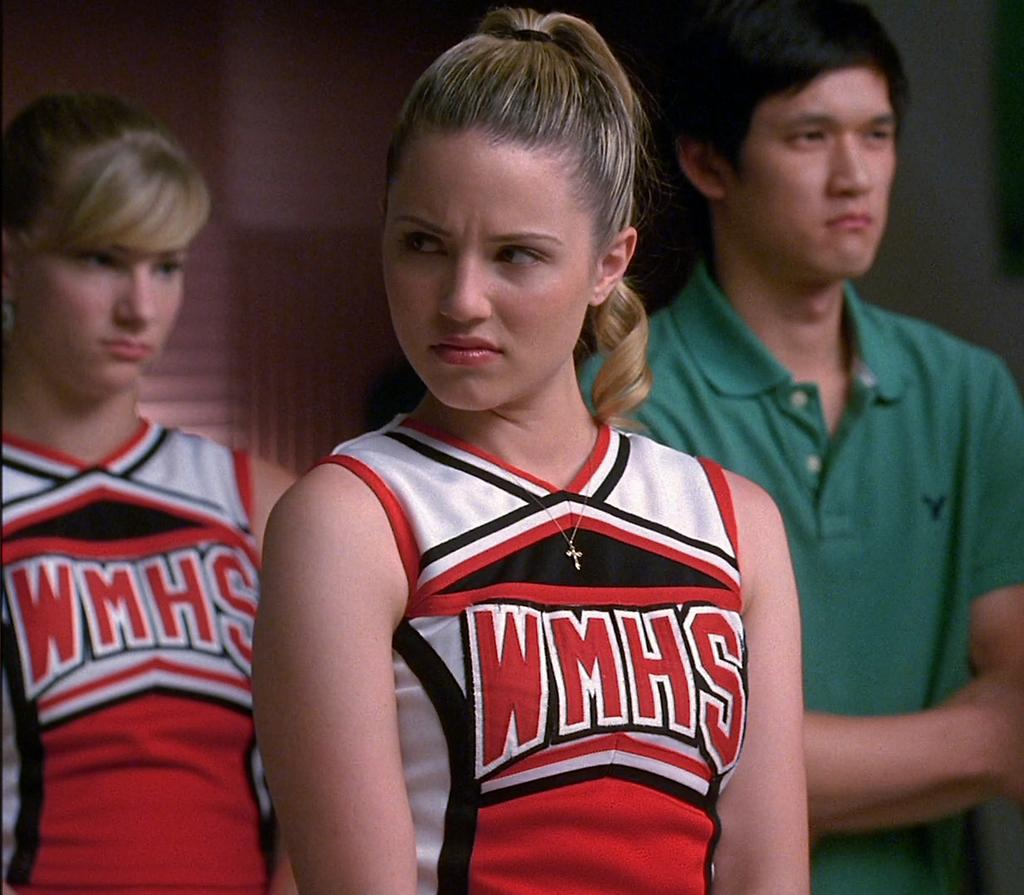<image>
Create a compact narrative representing the image presented. A girl with a WMHS cheer leading uniform looks angry. 